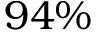<formula> <loc_0><loc_0><loc_500><loc_500>9 4 \%</formula> 